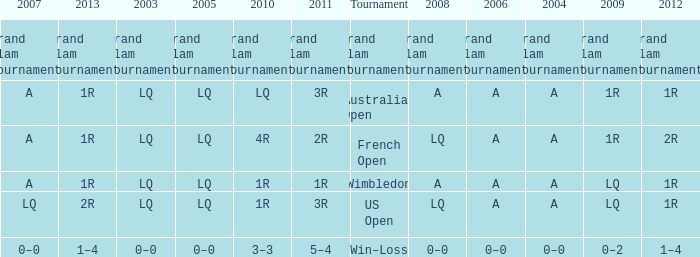Which year has a 2011 of 1r? A. 